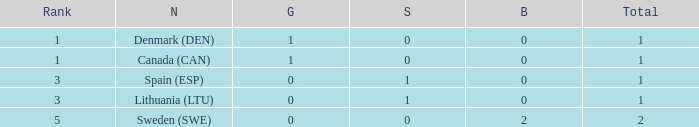What is the rank when there is 0 gold, the total is more than 1, and silver is more than 0? None. 